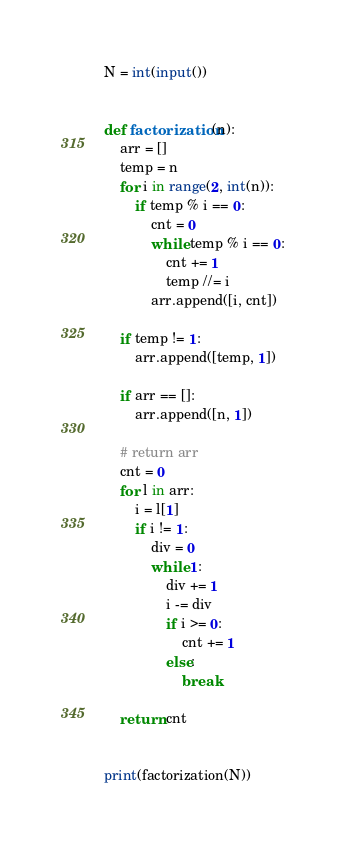Convert code to text. <code><loc_0><loc_0><loc_500><loc_500><_Python_>N = int(input())


def factorization(n):
    arr = []
    temp = n
    for i in range(2, int(n)):
        if temp % i == 0:
            cnt = 0
            while temp % i == 0:
                cnt += 1
                temp //= i
            arr.append([i, cnt])

    if temp != 1:
        arr.append([temp, 1])

    if arr == []:
        arr.append([n, 1])

    # return arr
    cnt = 0
    for l in arr:
        i = l[1]
        if i != 1:
            div = 0
            while 1:
                div += 1
                i -= div
                if i >= 0:
                    cnt += 1
                else:
                    break

    return cnt


print(factorization(N))
</code> 